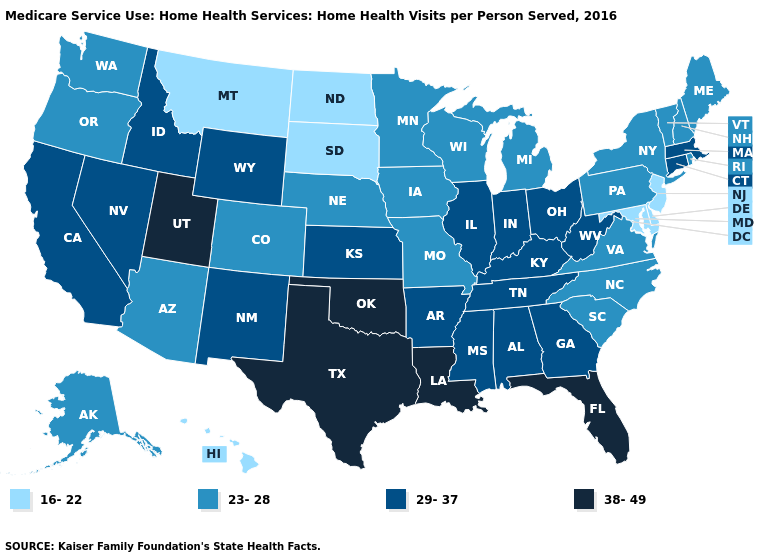Does the map have missing data?
Keep it brief. No. Name the states that have a value in the range 16-22?
Write a very short answer. Delaware, Hawaii, Maryland, Montana, New Jersey, North Dakota, South Dakota. What is the value of West Virginia?
Be succinct. 29-37. What is the value of Arizona?
Give a very brief answer. 23-28. Among the states that border Maryland , does Delaware have the highest value?
Write a very short answer. No. What is the lowest value in the USA?
Write a very short answer. 16-22. Is the legend a continuous bar?
Write a very short answer. No. What is the highest value in the USA?
Answer briefly. 38-49. What is the value of Connecticut?
Concise answer only. 29-37. Name the states that have a value in the range 16-22?
Give a very brief answer. Delaware, Hawaii, Maryland, Montana, New Jersey, North Dakota, South Dakota. What is the value of New York?
Give a very brief answer. 23-28. What is the lowest value in the Northeast?
Quick response, please. 16-22. Among the states that border South Dakota , which have the highest value?
Short answer required. Wyoming. Name the states that have a value in the range 16-22?
Write a very short answer. Delaware, Hawaii, Maryland, Montana, New Jersey, North Dakota, South Dakota. 